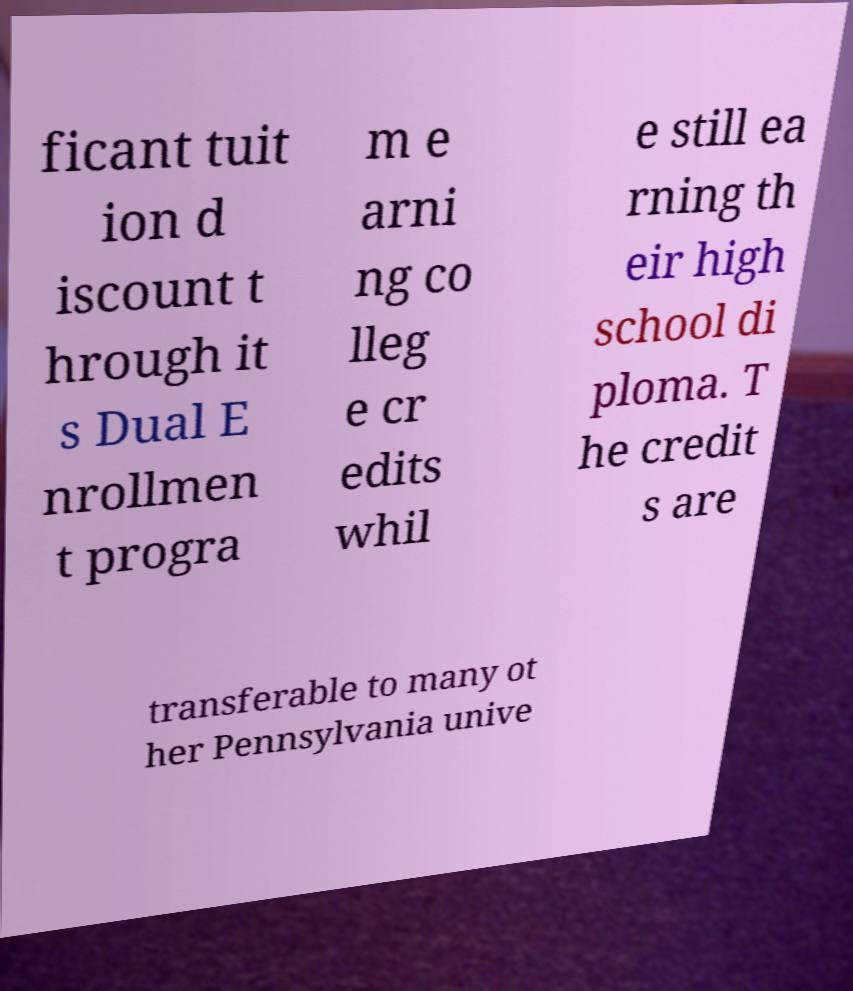I need the written content from this picture converted into text. Can you do that? ficant tuit ion d iscount t hrough it s Dual E nrollmen t progra m e arni ng co lleg e cr edits whil e still ea rning th eir high school di ploma. T he credit s are transferable to many ot her Pennsylvania unive 